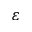Convert formula to latex. <formula><loc_0><loc_0><loc_500><loc_500>\varepsilon</formula> 